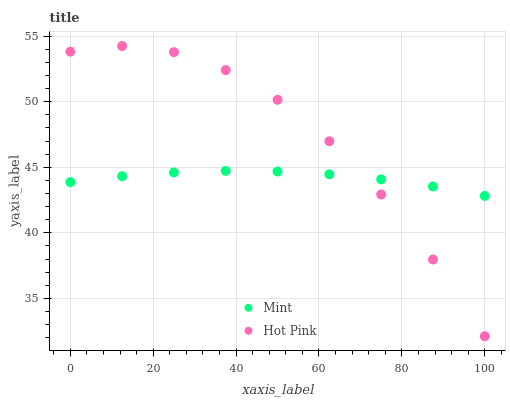Does Mint have the minimum area under the curve?
Answer yes or no. Yes. Does Hot Pink have the maximum area under the curve?
Answer yes or no. Yes. Does Mint have the maximum area under the curve?
Answer yes or no. No. Is Mint the smoothest?
Answer yes or no. Yes. Is Hot Pink the roughest?
Answer yes or no. Yes. Is Mint the roughest?
Answer yes or no. No. Does Hot Pink have the lowest value?
Answer yes or no. Yes. Does Mint have the lowest value?
Answer yes or no. No. Does Hot Pink have the highest value?
Answer yes or no. Yes. Does Mint have the highest value?
Answer yes or no. No. Does Mint intersect Hot Pink?
Answer yes or no. Yes. Is Mint less than Hot Pink?
Answer yes or no. No. Is Mint greater than Hot Pink?
Answer yes or no. No. 